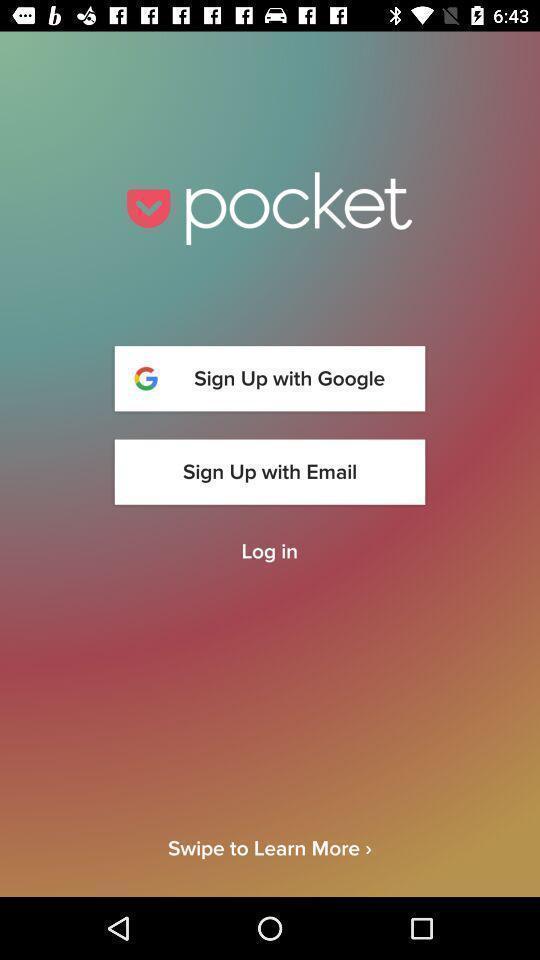Give me a narrative description of this picture. Welcome page. 